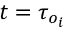<formula> <loc_0><loc_0><loc_500><loc_500>t = \tau _ { o _ { i } }</formula> 